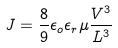<formula> <loc_0><loc_0><loc_500><loc_500>J = \frac { 8 } { 9 } \epsilon _ { o } \epsilon _ { r } \mu \frac { V ^ { 3 } } { L ^ { 3 } }</formula> 